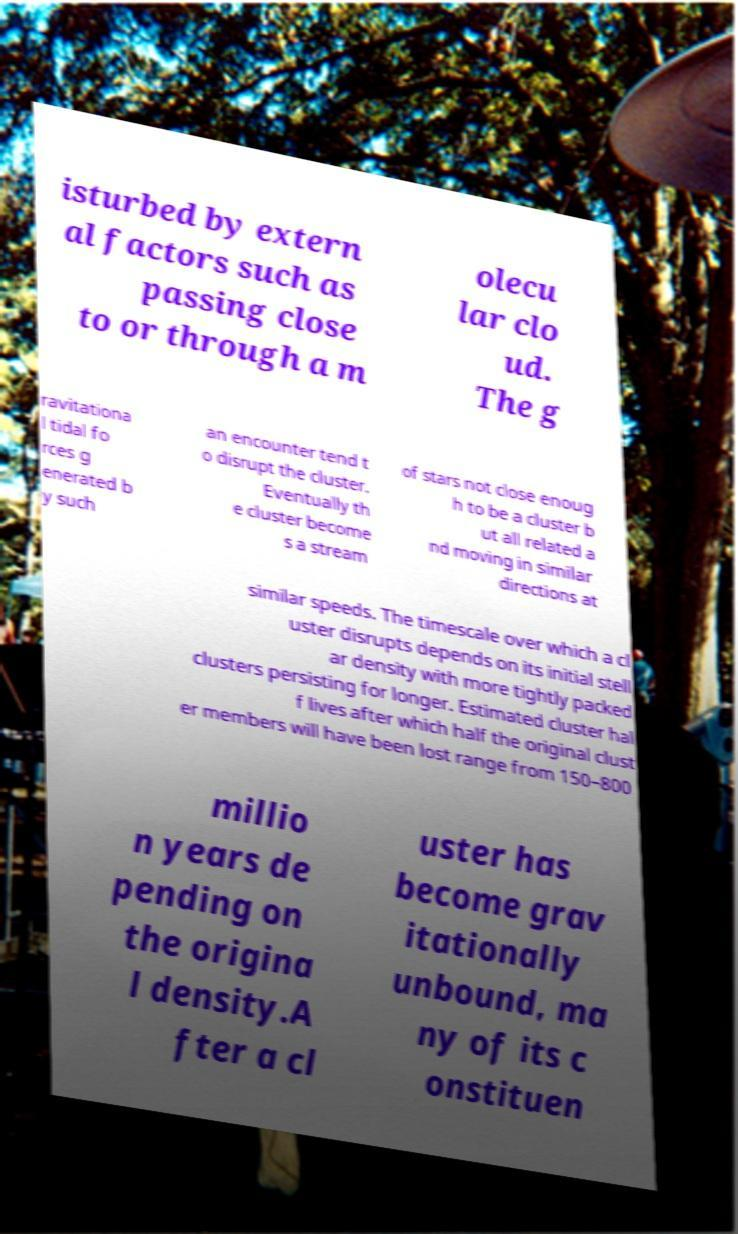What messages or text are displayed in this image? I need them in a readable, typed format. isturbed by extern al factors such as passing close to or through a m olecu lar clo ud. The g ravitationa l tidal fo rces g enerated b y such an encounter tend t o disrupt the cluster. Eventually th e cluster become s a stream of stars not close enoug h to be a cluster b ut all related a nd moving in similar directions at similar speeds. The timescale over which a cl uster disrupts depends on its initial stell ar density with more tightly packed clusters persisting for longer. Estimated cluster hal f lives after which half the original clust er members will have been lost range from 150–800 millio n years de pending on the origina l density.A fter a cl uster has become grav itationally unbound, ma ny of its c onstituen 